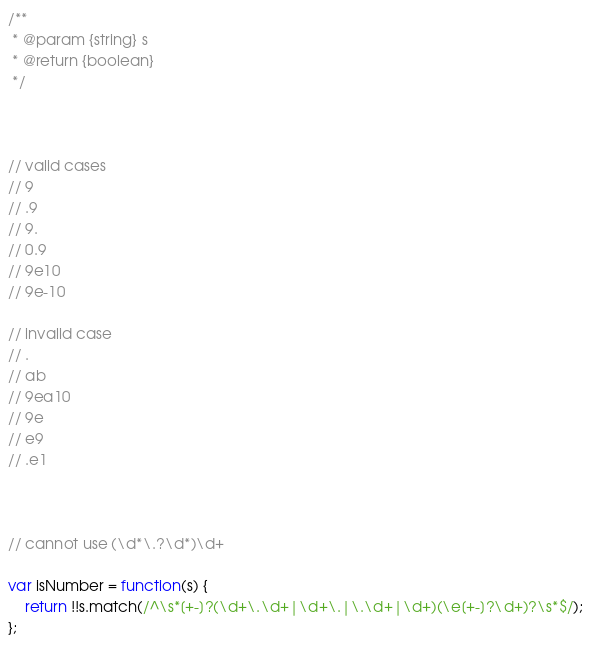Convert code to text. <code><loc_0><loc_0><loc_500><loc_500><_JavaScript_>/**
 * @param {string} s
 * @return {boolean}
 */



// valid cases
// 9
// .9
// 9.
// 0.9
// 9e10
// 9e-10

// invalid case
// .
// ab
// 9ea10
// 9e
// e9
// .e1



// cannot use (\d*\.?\d*)\d+

var isNumber = function(s) {
    return !!s.match(/^\s*[+-]?(\d+\.\d+|\d+\.|\.\d+|\d+)(\e[+-]?\d+)?\s*$/);
};</code> 